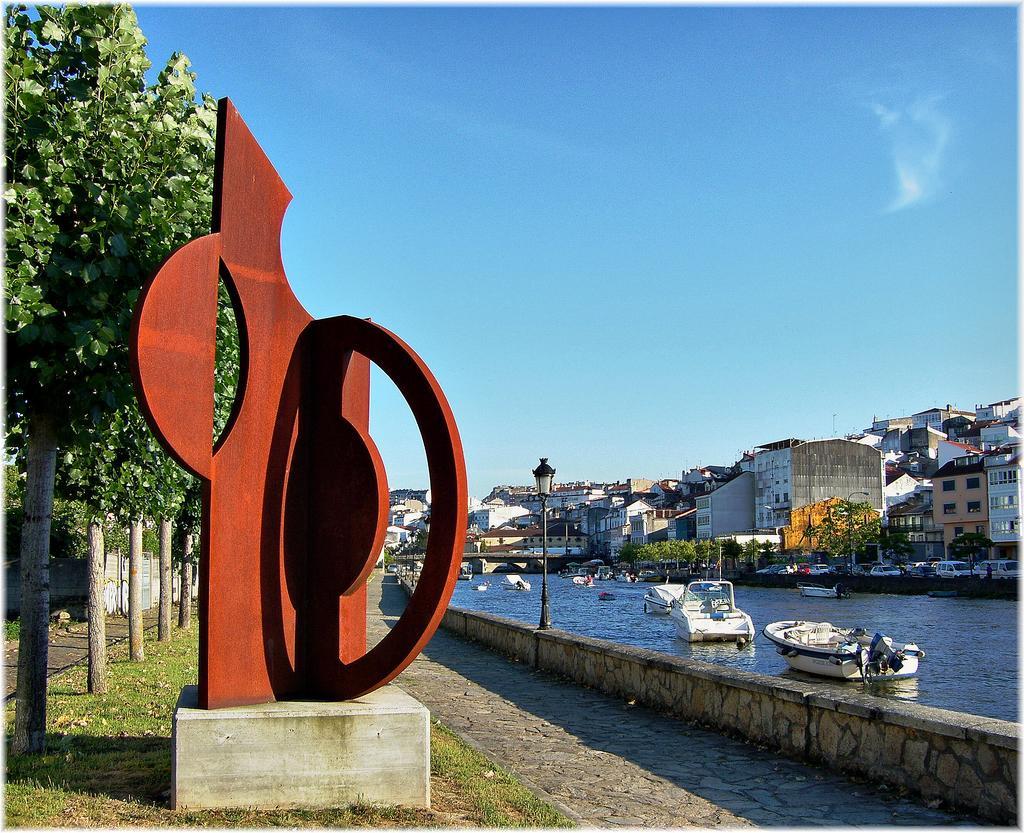Could you give a brief overview of what you see in this image? In this image we can see a memorial place. Left side of the image trees are there and grassy land is present. Background of the image buildings, poles and trees are there. In front of the building boats are there on the surface of water. At the top of the image sky is there which is in blue color. 